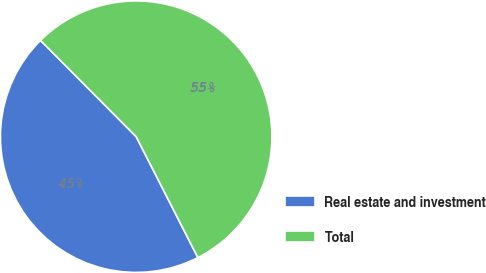<chart> <loc_0><loc_0><loc_500><loc_500><pie_chart><fcel>Real estate and investment<fcel>Total<nl><fcel>45.06%<fcel>54.94%<nl></chart> 